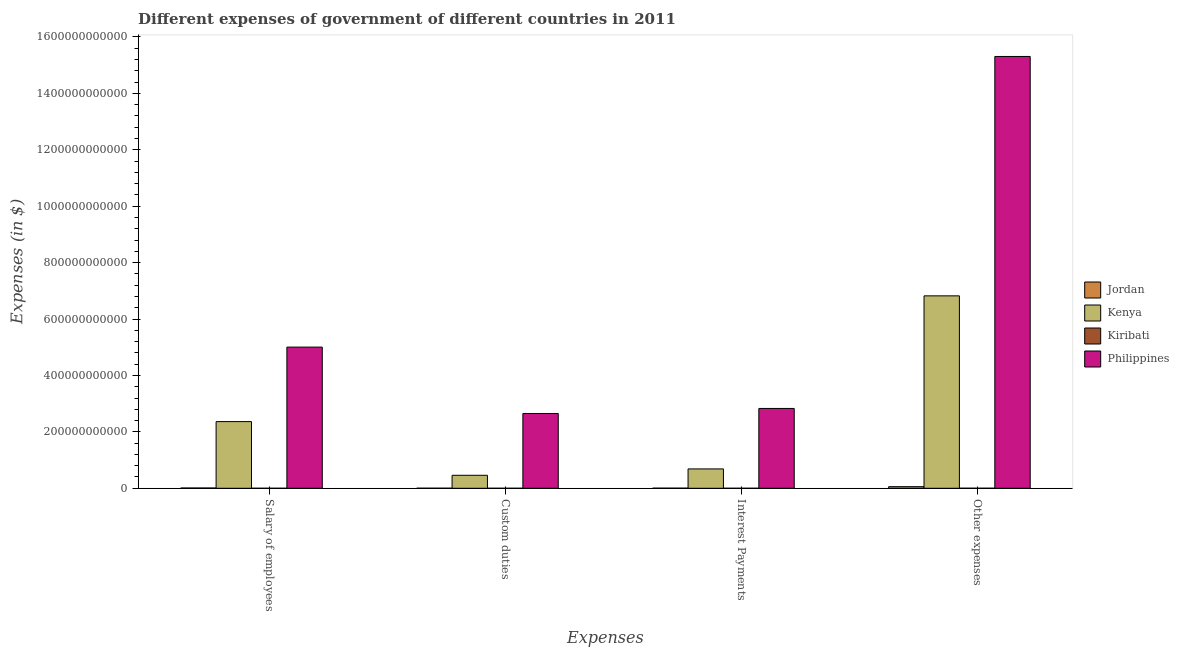How many different coloured bars are there?
Give a very brief answer. 4. Are the number of bars per tick equal to the number of legend labels?
Give a very brief answer. Yes. Are the number of bars on each tick of the X-axis equal?
Offer a very short reply. Yes. What is the label of the 4th group of bars from the left?
Keep it short and to the point. Other expenses. What is the amount spent on other expenses in Kenya?
Provide a succinct answer. 6.82e+11. Across all countries, what is the maximum amount spent on custom duties?
Keep it short and to the point. 2.65e+11. Across all countries, what is the minimum amount spent on salary of employees?
Make the answer very short. 4.76e+07. In which country was the amount spent on other expenses maximum?
Your answer should be compact. Philippines. In which country was the amount spent on custom duties minimum?
Make the answer very short. Kiribati. What is the total amount spent on other expenses in the graph?
Keep it short and to the point. 2.22e+12. What is the difference between the amount spent on salary of employees in Kiribati and that in Kenya?
Offer a terse response. -2.36e+11. What is the difference between the amount spent on interest payments in Jordan and the amount spent on other expenses in Philippines?
Offer a very short reply. -1.53e+12. What is the average amount spent on interest payments per country?
Your answer should be compact. 8.80e+1. What is the difference between the amount spent on salary of employees and amount spent on interest payments in Philippines?
Make the answer very short. 2.17e+11. In how many countries, is the amount spent on interest payments greater than 1320000000000 $?
Your answer should be very brief. 0. What is the ratio of the amount spent on salary of employees in Kiribati to that in Philippines?
Offer a very short reply. 9.520948316102036e-5. Is the amount spent on other expenses in Jordan less than that in Philippines?
Keep it short and to the point. Yes. What is the difference between the highest and the second highest amount spent on salary of employees?
Your answer should be very brief. 2.64e+11. What is the difference between the highest and the lowest amount spent on other expenses?
Offer a very short reply. 1.53e+12. In how many countries, is the amount spent on custom duties greater than the average amount spent on custom duties taken over all countries?
Keep it short and to the point. 1. Is it the case that in every country, the sum of the amount spent on salary of employees and amount spent on other expenses is greater than the sum of amount spent on custom duties and amount spent on interest payments?
Make the answer very short. No. What does the 3rd bar from the left in Other expenses represents?
Provide a succinct answer. Kiribati. What does the 1st bar from the right in Interest Payments represents?
Your response must be concise. Philippines. Is it the case that in every country, the sum of the amount spent on salary of employees and amount spent on custom duties is greater than the amount spent on interest payments?
Give a very brief answer. Yes. Are all the bars in the graph horizontal?
Your answer should be very brief. No. What is the difference between two consecutive major ticks on the Y-axis?
Keep it short and to the point. 2.00e+11. Are the values on the major ticks of Y-axis written in scientific E-notation?
Your answer should be compact. No. Does the graph contain any zero values?
Provide a succinct answer. No. How many legend labels are there?
Ensure brevity in your answer.  4. How are the legend labels stacked?
Provide a succinct answer. Vertical. What is the title of the graph?
Provide a succinct answer. Different expenses of government of different countries in 2011. What is the label or title of the X-axis?
Offer a very short reply. Expenses. What is the label or title of the Y-axis?
Provide a short and direct response. Expenses (in $). What is the Expenses (in $) in Jordan in Salary of employees?
Provide a short and direct response. 1.01e+09. What is the Expenses (in $) in Kenya in Salary of employees?
Your answer should be compact. 2.36e+11. What is the Expenses (in $) in Kiribati in Salary of employees?
Keep it short and to the point. 4.76e+07. What is the Expenses (in $) of Philippines in Salary of employees?
Give a very brief answer. 5.00e+11. What is the Expenses (in $) in Jordan in Custom duties?
Provide a succinct answer. 2.74e+08. What is the Expenses (in $) of Kenya in Custom duties?
Your response must be concise. 4.61e+1. What is the Expenses (in $) of Kiribati in Custom duties?
Your answer should be very brief. 1.54e+07. What is the Expenses (in $) in Philippines in Custom duties?
Your answer should be very brief. 2.65e+11. What is the Expenses (in $) of Jordan in Interest Payments?
Offer a very short reply. 4.30e+08. What is the Expenses (in $) of Kenya in Interest Payments?
Offer a terse response. 6.87e+1. What is the Expenses (in $) of Kiribati in Interest Payments?
Your answer should be compact. 2.66e+06. What is the Expenses (in $) in Philippines in Interest Payments?
Offer a very short reply. 2.83e+11. What is the Expenses (in $) of Jordan in Other expenses?
Give a very brief answer. 5.74e+09. What is the Expenses (in $) in Kenya in Other expenses?
Provide a short and direct response. 6.82e+11. What is the Expenses (in $) of Kiribati in Other expenses?
Keep it short and to the point. 1.17e+08. What is the Expenses (in $) in Philippines in Other expenses?
Your answer should be very brief. 1.53e+12. Across all Expenses, what is the maximum Expenses (in $) in Jordan?
Offer a terse response. 5.74e+09. Across all Expenses, what is the maximum Expenses (in $) of Kenya?
Your answer should be compact. 6.82e+11. Across all Expenses, what is the maximum Expenses (in $) of Kiribati?
Your answer should be compact. 1.17e+08. Across all Expenses, what is the maximum Expenses (in $) of Philippines?
Your answer should be very brief. 1.53e+12. Across all Expenses, what is the minimum Expenses (in $) in Jordan?
Your response must be concise. 2.74e+08. Across all Expenses, what is the minimum Expenses (in $) of Kenya?
Your answer should be compact. 4.61e+1. Across all Expenses, what is the minimum Expenses (in $) in Kiribati?
Offer a terse response. 2.66e+06. Across all Expenses, what is the minimum Expenses (in $) of Philippines?
Your answer should be very brief. 2.65e+11. What is the total Expenses (in $) in Jordan in the graph?
Keep it short and to the point. 7.46e+09. What is the total Expenses (in $) in Kenya in the graph?
Make the answer very short. 1.03e+12. What is the total Expenses (in $) of Kiribati in the graph?
Offer a very short reply. 1.83e+08. What is the total Expenses (in $) in Philippines in the graph?
Your response must be concise. 2.58e+12. What is the difference between the Expenses (in $) in Jordan in Salary of employees and that in Custom duties?
Offer a very short reply. 7.39e+08. What is the difference between the Expenses (in $) of Kenya in Salary of employees and that in Custom duties?
Your answer should be compact. 1.90e+11. What is the difference between the Expenses (in $) of Kiribati in Salary of employees and that in Custom duties?
Provide a short and direct response. 3.22e+07. What is the difference between the Expenses (in $) of Philippines in Salary of employees and that in Custom duties?
Your response must be concise. 2.35e+11. What is the difference between the Expenses (in $) of Jordan in Salary of employees and that in Interest Payments?
Your response must be concise. 5.84e+08. What is the difference between the Expenses (in $) in Kenya in Salary of employees and that in Interest Payments?
Provide a short and direct response. 1.68e+11. What is the difference between the Expenses (in $) of Kiribati in Salary of employees and that in Interest Payments?
Make the answer very short. 4.50e+07. What is the difference between the Expenses (in $) of Philippines in Salary of employees and that in Interest Payments?
Your response must be concise. 2.17e+11. What is the difference between the Expenses (in $) in Jordan in Salary of employees and that in Other expenses?
Your response must be concise. -4.73e+09. What is the difference between the Expenses (in $) in Kenya in Salary of employees and that in Other expenses?
Ensure brevity in your answer.  -4.46e+11. What is the difference between the Expenses (in $) in Kiribati in Salary of employees and that in Other expenses?
Make the answer very short. -6.93e+07. What is the difference between the Expenses (in $) of Philippines in Salary of employees and that in Other expenses?
Provide a succinct answer. -1.03e+12. What is the difference between the Expenses (in $) in Jordan in Custom duties and that in Interest Payments?
Give a very brief answer. -1.55e+08. What is the difference between the Expenses (in $) in Kenya in Custom duties and that in Interest Payments?
Give a very brief answer. -2.26e+1. What is the difference between the Expenses (in $) in Kiribati in Custom duties and that in Interest Payments?
Ensure brevity in your answer.  1.28e+07. What is the difference between the Expenses (in $) of Philippines in Custom duties and that in Interest Payments?
Ensure brevity in your answer.  -1.79e+1. What is the difference between the Expenses (in $) in Jordan in Custom duties and that in Other expenses?
Provide a succinct answer. -5.47e+09. What is the difference between the Expenses (in $) of Kenya in Custom duties and that in Other expenses?
Give a very brief answer. -6.36e+11. What is the difference between the Expenses (in $) of Kiribati in Custom duties and that in Other expenses?
Your answer should be compact. -1.02e+08. What is the difference between the Expenses (in $) in Philippines in Custom duties and that in Other expenses?
Offer a terse response. -1.27e+12. What is the difference between the Expenses (in $) of Jordan in Interest Payments and that in Other expenses?
Offer a terse response. -5.31e+09. What is the difference between the Expenses (in $) in Kenya in Interest Payments and that in Other expenses?
Your answer should be very brief. -6.13e+11. What is the difference between the Expenses (in $) in Kiribati in Interest Payments and that in Other expenses?
Give a very brief answer. -1.14e+08. What is the difference between the Expenses (in $) of Philippines in Interest Payments and that in Other expenses?
Offer a very short reply. -1.25e+12. What is the difference between the Expenses (in $) of Jordan in Salary of employees and the Expenses (in $) of Kenya in Custom duties?
Ensure brevity in your answer.  -4.51e+1. What is the difference between the Expenses (in $) of Jordan in Salary of employees and the Expenses (in $) of Kiribati in Custom duties?
Provide a succinct answer. 9.98e+08. What is the difference between the Expenses (in $) of Jordan in Salary of employees and the Expenses (in $) of Philippines in Custom duties?
Offer a terse response. -2.64e+11. What is the difference between the Expenses (in $) of Kenya in Salary of employees and the Expenses (in $) of Kiribati in Custom duties?
Your response must be concise. 2.36e+11. What is the difference between the Expenses (in $) of Kenya in Salary of employees and the Expenses (in $) of Philippines in Custom duties?
Provide a succinct answer. -2.87e+1. What is the difference between the Expenses (in $) of Kiribati in Salary of employees and the Expenses (in $) of Philippines in Custom duties?
Your answer should be compact. -2.65e+11. What is the difference between the Expenses (in $) of Jordan in Salary of employees and the Expenses (in $) of Kenya in Interest Payments?
Give a very brief answer. -6.77e+1. What is the difference between the Expenses (in $) in Jordan in Salary of employees and the Expenses (in $) in Kiribati in Interest Payments?
Offer a very short reply. 1.01e+09. What is the difference between the Expenses (in $) in Jordan in Salary of employees and the Expenses (in $) in Philippines in Interest Payments?
Keep it short and to the point. -2.82e+11. What is the difference between the Expenses (in $) in Kenya in Salary of employees and the Expenses (in $) in Kiribati in Interest Payments?
Offer a very short reply. 2.36e+11. What is the difference between the Expenses (in $) in Kenya in Salary of employees and the Expenses (in $) in Philippines in Interest Payments?
Provide a succinct answer. -4.66e+1. What is the difference between the Expenses (in $) of Kiribati in Salary of employees and the Expenses (in $) of Philippines in Interest Payments?
Offer a very short reply. -2.83e+11. What is the difference between the Expenses (in $) in Jordan in Salary of employees and the Expenses (in $) in Kenya in Other expenses?
Your answer should be very brief. -6.81e+11. What is the difference between the Expenses (in $) in Jordan in Salary of employees and the Expenses (in $) in Kiribati in Other expenses?
Provide a short and direct response. 8.97e+08. What is the difference between the Expenses (in $) of Jordan in Salary of employees and the Expenses (in $) of Philippines in Other expenses?
Provide a short and direct response. -1.53e+12. What is the difference between the Expenses (in $) of Kenya in Salary of employees and the Expenses (in $) of Kiribati in Other expenses?
Provide a short and direct response. 2.36e+11. What is the difference between the Expenses (in $) of Kenya in Salary of employees and the Expenses (in $) of Philippines in Other expenses?
Provide a short and direct response. -1.29e+12. What is the difference between the Expenses (in $) of Kiribati in Salary of employees and the Expenses (in $) of Philippines in Other expenses?
Give a very brief answer. -1.53e+12. What is the difference between the Expenses (in $) in Jordan in Custom duties and the Expenses (in $) in Kenya in Interest Payments?
Your answer should be compact. -6.84e+1. What is the difference between the Expenses (in $) of Jordan in Custom duties and the Expenses (in $) of Kiribati in Interest Payments?
Your answer should be compact. 2.72e+08. What is the difference between the Expenses (in $) of Jordan in Custom duties and the Expenses (in $) of Philippines in Interest Payments?
Your answer should be very brief. -2.83e+11. What is the difference between the Expenses (in $) in Kenya in Custom duties and the Expenses (in $) in Kiribati in Interest Payments?
Your answer should be very brief. 4.61e+1. What is the difference between the Expenses (in $) in Kenya in Custom duties and the Expenses (in $) in Philippines in Interest Payments?
Keep it short and to the point. -2.37e+11. What is the difference between the Expenses (in $) in Kiribati in Custom duties and the Expenses (in $) in Philippines in Interest Payments?
Offer a very short reply. -2.83e+11. What is the difference between the Expenses (in $) of Jordan in Custom duties and the Expenses (in $) of Kenya in Other expenses?
Ensure brevity in your answer.  -6.82e+11. What is the difference between the Expenses (in $) of Jordan in Custom duties and the Expenses (in $) of Kiribati in Other expenses?
Provide a short and direct response. 1.57e+08. What is the difference between the Expenses (in $) in Jordan in Custom duties and the Expenses (in $) in Philippines in Other expenses?
Provide a succinct answer. -1.53e+12. What is the difference between the Expenses (in $) in Kenya in Custom duties and the Expenses (in $) in Kiribati in Other expenses?
Your answer should be very brief. 4.60e+1. What is the difference between the Expenses (in $) in Kenya in Custom duties and the Expenses (in $) in Philippines in Other expenses?
Keep it short and to the point. -1.48e+12. What is the difference between the Expenses (in $) in Kiribati in Custom duties and the Expenses (in $) in Philippines in Other expenses?
Provide a short and direct response. -1.53e+12. What is the difference between the Expenses (in $) of Jordan in Interest Payments and the Expenses (in $) of Kenya in Other expenses?
Provide a succinct answer. -6.82e+11. What is the difference between the Expenses (in $) of Jordan in Interest Payments and the Expenses (in $) of Kiribati in Other expenses?
Make the answer very short. 3.13e+08. What is the difference between the Expenses (in $) in Jordan in Interest Payments and the Expenses (in $) in Philippines in Other expenses?
Provide a short and direct response. -1.53e+12. What is the difference between the Expenses (in $) of Kenya in Interest Payments and the Expenses (in $) of Kiribati in Other expenses?
Your answer should be very brief. 6.86e+1. What is the difference between the Expenses (in $) of Kenya in Interest Payments and the Expenses (in $) of Philippines in Other expenses?
Provide a short and direct response. -1.46e+12. What is the difference between the Expenses (in $) in Kiribati in Interest Payments and the Expenses (in $) in Philippines in Other expenses?
Your answer should be very brief. -1.53e+12. What is the average Expenses (in $) of Jordan per Expenses?
Offer a terse response. 1.86e+09. What is the average Expenses (in $) in Kenya per Expenses?
Keep it short and to the point. 2.58e+11. What is the average Expenses (in $) of Kiribati per Expenses?
Provide a short and direct response. 4.57e+07. What is the average Expenses (in $) in Philippines per Expenses?
Provide a succinct answer. 6.45e+11. What is the difference between the Expenses (in $) in Jordan and Expenses (in $) in Kenya in Salary of employees?
Offer a terse response. -2.35e+11. What is the difference between the Expenses (in $) in Jordan and Expenses (in $) in Kiribati in Salary of employees?
Provide a short and direct response. 9.66e+08. What is the difference between the Expenses (in $) of Jordan and Expenses (in $) of Philippines in Salary of employees?
Keep it short and to the point. -4.99e+11. What is the difference between the Expenses (in $) in Kenya and Expenses (in $) in Kiribati in Salary of employees?
Provide a succinct answer. 2.36e+11. What is the difference between the Expenses (in $) of Kenya and Expenses (in $) of Philippines in Salary of employees?
Offer a terse response. -2.64e+11. What is the difference between the Expenses (in $) of Kiribati and Expenses (in $) of Philippines in Salary of employees?
Your answer should be very brief. -5.00e+11. What is the difference between the Expenses (in $) in Jordan and Expenses (in $) in Kenya in Custom duties?
Ensure brevity in your answer.  -4.58e+1. What is the difference between the Expenses (in $) of Jordan and Expenses (in $) of Kiribati in Custom duties?
Provide a short and direct response. 2.59e+08. What is the difference between the Expenses (in $) in Jordan and Expenses (in $) in Philippines in Custom duties?
Provide a short and direct response. -2.65e+11. What is the difference between the Expenses (in $) in Kenya and Expenses (in $) in Kiribati in Custom duties?
Your response must be concise. 4.61e+1. What is the difference between the Expenses (in $) in Kenya and Expenses (in $) in Philippines in Custom duties?
Your answer should be compact. -2.19e+11. What is the difference between the Expenses (in $) in Kiribati and Expenses (in $) in Philippines in Custom duties?
Your answer should be very brief. -2.65e+11. What is the difference between the Expenses (in $) of Jordan and Expenses (in $) of Kenya in Interest Payments?
Keep it short and to the point. -6.82e+1. What is the difference between the Expenses (in $) in Jordan and Expenses (in $) in Kiribati in Interest Payments?
Your answer should be very brief. 4.27e+08. What is the difference between the Expenses (in $) in Jordan and Expenses (in $) in Philippines in Interest Payments?
Provide a short and direct response. -2.83e+11. What is the difference between the Expenses (in $) in Kenya and Expenses (in $) in Kiribati in Interest Payments?
Your answer should be compact. 6.87e+1. What is the difference between the Expenses (in $) of Kenya and Expenses (in $) of Philippines in Interest Payments?
Provide a short and direct response. -2.14e+11. What is the difference between the Expenses (in $) of Kiribati and Expenses (in $) of Philippines in Interest Payments?
Provide a short and direct response. -2.83e+11. What is the difference between the Expenses (in $) of Jordan and Expenses (in $) of Kenya in Other expenses?
Your answer should be compact. -6.76e+11. What is the difference between the Expenses (in $) of Jordan and Expenses (in $) of Kiribati in Other expenses?
Provide a short and direct response. 5.62e+09. What is the difference between the Expenses (in $) in Jordan and Expenses (in $) in Philippines in Other expenses?
Your answer should be very brief. -1.53e+12. What is the difference between the Expenses (in $) of Kenya and Expenses (in $) of Kiribati in Other expenses?
Your response must be concise. 6.82e+11. What is the difference between the Expenses (in $) of Kenya and Expenses (in $) of Philippines in Other expenses?
Provide a short and direct response. -8.49e+11. What is the difference between the Expenses (in $) of Kiribati and Expenses (in $) of Philippines in Other expenses?
Give a very brief answer. -1.53e+12. What is the ratio of the Expenses (in $) of Jordan in Salary of employees to that in Custom duties?
Offer a very short reply. 3.7. What is the ratio of the Expenses (in $) in Kenya in Salary of employees to that in Custom duties?
Your answer should be very brief. 5.13. What is the ratio of the Expenses (in $) in Kiribati in Salary of employees to that in Custom duties?
Provide a succinct answer. 3.09. What is the ratio of the Expenses (in $) of Philippines in Salary of employees to that in Custom duties?
Offer a very short reply. 1.89. What is the ratio of the Expenses (in $) in Jordan in Salary of employees to that in Interest Payments?
Your answer should be very brief. 2.36. What is the ratio of the Expenses (in $) of Kenya in Salary of employees to that in Interest Payments?
Offer a terse response. 3.44. What is the ratio of the Expenses (in $) in Kiribati in Salary of employees to that in Interest Payments?
Your response must be concise. 17.93. What is the ratio of the Expenses (in $) in Philippines in Salary of employees to that in Interest Payments?
Make the answer very short. 1.77. What is the ratio of the Expenses (in $) in Jordan in Salary of employees to that in Other expenses?
Make the answer very short. 0.18. What is the ratio of the Expenses (in $) of Kenya in Salary of employees to that in Other expenses?
Keep it short and to the point. 0.35. What is the ratio of the Expenses (in $) of Kiribati in Salary of employees to that in Other expenses?
Your response must be concise. 0.41. What is the ratio of the Expenses (in $) of Philippines in Salary of employees to that in Other expenses?
Make the answer very short. 0.33. What is the ratio of the Expenses (in $) in Jordan in Custom duties to that in Interest Payments?
Offer a very short reply. 0.64. What is the ratio of the Expenses (in $) in Kenya in Custom duties to that in Interest Payments?
Your answer should be very brief. 0.67. What is the ratio of the Expenses (in $) in Kiribati in Custom duties to that in Interest Payments?
Make the answer very short. 5.81. What is the ratio of the Expenses (in $) of Philippines in Custom duties to that in Interest Payments?
Make the answer very short. 0.94. What is the ratio of the Expenses (in $) of Jordan in Custom duties to that in Other expenses?
Keep it short and to the point. 0.05. What is the ratio of the Expenses (in $) of Kenya in Custom duties to that in Other expenses?
Your answer should be very brief. 0.07. What is the ratio of the Expenses (in $) in Kiribati in Custom duties to that in Other expenses?
Keep it short and to the point. 0.13. What is the ratio of the Expenses (in $) in Philippines in Custom duties to that in Other expenses?
Give a very brief answer. 0.17. What is the ratio of the Expenses (in $) of Jordan in Interest Payments to that in Other expenses?
Offer a terse response. 0.07. What is the ratio of the Expenses (in $) of Kenya in Interest Payments to that in Other expenses?
Your answer should be compact. 0.1. What is the ratio of the Expenses (in $) of Kiribati in Interest Payments to that in Other expenses?
Your answer should be compact. 0.02. What is the ratio of the Expenses (in $) of Philippines in Interest Payments to that in Other expenses?
Offer a terse response. 0.18. What is the difference between the highest and the second highest Expenses (in $) of Jordan?
Your response must be concise. 4.73e+09. What is the difference between the highest and the second highest Expenses (in $) of Kenya?
Offer a very short reply. 4.46e+11. What is the difference between the highest and the second highest Expenses (in $) of Kiribati?
Offer a terse response. 6.93e+07. What is the difference between the highest and the second highest Expenses (in $) of Philippines?
Keep it short and to the point. 1.03e+12. What is the difference between the highest and the lowest Expenses (in $) in Jordan?
Offer a terse response. 5.47e+09. What is the difference between the highest and the lowest Expenses (in $) of Kenya?
Your response must be concise. 6.36e+11. What is the difference between the highest and the lowest Expenses (in $) of Kiribati?
Your answer should be very brief. 1.14e+08. What is the difference between the highest and the lowest Expenses (in $) of Philippines?
Your response must be concise. 1.27e+12. 